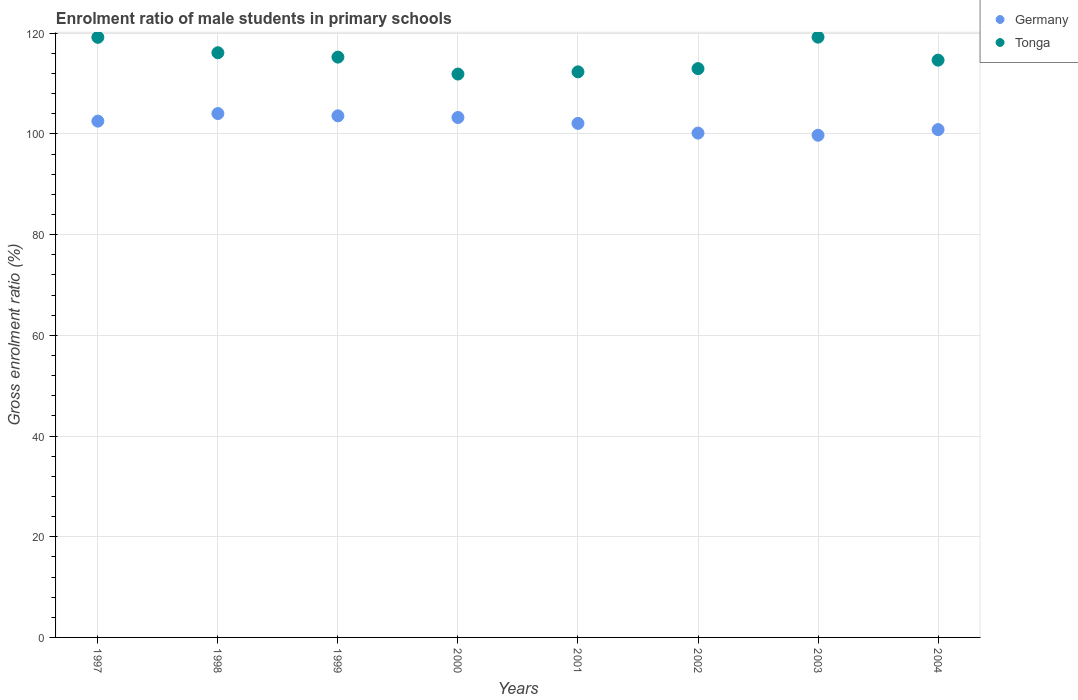What is the enrolment ratio of male students in primary schools in Tonga in 1999?
Give a very brief answer. 115.27. Across all years, what is the maximum enrolment ratio of male students in primary schools in Tonga?
Make the answer very short. 119.24. Across all years, what is the minimum enrolment ratio of male students in primary schools in Tonga?
Offer a terse response. 111.91. In which year was the enrolment ratio of male students in primary schools in Tonga maximum?
Your answer should be compact. 2003. In which year was the enrolment ratio of male students in primary schools in Tonga minimum?
Your answer should be very brief. 2000. What is the total enrolment ratio of male students in primary schools in Germany in the graph?
Your answer should be very brief. 816.41. What is the difference between the enrolment ratio of male students in primary schools in Tonga in 2002 and that in 2004?
Make the answer very short. -1.69. What is the difference between the enrolment ratio of male students in primary schools in Tonga in 2003 and the enrolment ratio of male students in primary schools in Germany in 1999?
Your response must be concise. 15.63. What is the average enrolment ratio of male students in primary schools in Tonga per year?
Your answer should be compact. 115.22. In the year 1999, what is the difference between the enrolment ratio of male students in primary schools in Germany and enrolment ratio of male students in primary schools in Tonga?
Offer a very short reply. -11.66. In how many years, is the enrolment ratio of male students in primary schools in Tonga greater than 60 %?
Make the answer very short. 8. What is the ratio of the enrolment ratio of male students in primary schools in Tonga in 2003 to that in 2004?
Provide a short and direct response. 1.04. Is the enrolment ratio of male students in primary schools in Tonga in 1997 less than that in 2001?
Make the answer very short. No. What is the difference between the highest and the second highest enrolment ratio of male students in primary schools in Tonga?
Offer a terse response. 0.03. What is the difference between the highest and the lowest enrolment ratio of male students in primary schools in Tonga?
Ensure brevity in your answer.  7.33. How many dotlines are there?
Your answer should be very brief. 2. What is the difference between two consecutive major ticks on the Y-axis?
Provide a succinct answer. 20. Are the values on the major ticks of Y-axis written in scientific E-notation?
Make the answer very short. No. Does the graph contain any zero values?
Your answer should be compact. No. How are the legend labels stacked?
Provide a short and direct response. Vertical. What is the title of the graph?
Provide a succinct answer. Enrolment ratio of male students in primary schools. What is the label or title of the Y-axis?
Your answer should be compact. Gross enrolment ratio (%). What is the Gross enrolment ratio (%) in Germany in 1997?
Provide a short and direct response. 102.56. What is the Gross enrolment ratio (%) in Tonga in 1997?
Your answer should be compact. 119.2. What is the Gross enrolment ratio (%) in Germany in 1998?
Provide a succinct answer. 104.06. What is the Gross enrolment ratio (%) in Tonga in 1998?
Your answer should be very brief. 116.14. What is the Gross enrolment ratio (%) of Germany in 1999?
Offer a terse response. 103.61. What is the Gross enrolment ratio (%) of Tonga in 1999?
Your answer should be compact. 115.27. What is the Gross enrolment ratio (%) of Germany in 2000?
Your answer should be very brief. 103.28. What is the Gross enrolment ratio (%) in Tonga in 2000?
Your response must be concise. 111.91. What is the Gross enrolment ratio (%) in Germany in 2001?
Make the answer very short. 102.1. What is the Gross enrolment ratio (%) in Tonga in 2001?
Give a very brief answer. 112.34. What is the Gross enrolment ratio (%) of Germany in 2002?
Provide a succinct answer. 100.18. What is the Gross enrolment ratio (%) of Tonga in 2002?
Keep it short and to the point. 112.98. What is the Gross enrolment ratio (%) of Germany in 2003?
Your answer should be compact. 99.75. What is the Gross enrolment ratio (%) of Tonga in 2003?
Provide a short and direct response. 119.24. What is the Gross enrolment ratio (%) of Germany in 2004?
Provide a short and direct response. 100.87. What is the Gross enrolment ratio (%) in Tonga in 2004?
Your response must be concise. 114.67. Across all years, what is the maximum Gross enrolment ratio (%) of Germany?
Make the answer very short. 104.06. Across all years, what is the maximum Gross enrolment ratio (%) in Tonga?
Keep it short and to the point. 119.24. Across all years, what is the minimum Gross enrolment ratio (%) in Germany?
Offer a very short reply. 99.75. Across all years, what is the minimum Gross enrolment ratio (%) in Tonga?
Offer a terse response. 111.91. What is the total Gross enrolment ratio (%) in Germany in the graph?
Your answer should be compact. 816.41. What is the total Gross enrolment ratio (%) of Tonga in the graph?
Provide a short and direct response. 921.76. What is the difference between the Gross enrolment ratio (%) in Germany in 1997 and that in 1998?
Your answer should be very brief. -1.5. What is the difference between the Gross enrolment ratio (%) in Tonga in 1997 and that in 1998?
Ensure brevity in your answer.  3.06. What is the difference between the Gross enrolment ratio (%) of Germany in 1997 and that in 1999?
Keep it short and to the point. -1.05. What is the difference between the Gross enrolment ratio (%) of Tonga in 1997 and that in 1999?
Provide a succinct answer. 3.93. What is the difference between the Gross enrolment ratio (%) in Germany in 1997 and that in 2000?
Ensure brevity in your answer.  -0.72. What is the difference between the Gross enrolment ratio (%) of Tonga in 1997 and that in 2000?
Provide a short and direct response. 7.29. What is the difference between the Gross enrolment ratio (%) of Germany in 1997 and that in 2001?
Your response must be concise. 0.45. What is the difference between the Gross enrolment ratio (%) of Tonga in 1997 and that in 2001?
Offer a terse response. 6.86. What is the difference between the Gross enrolment ratio (%) in Germany in 1997 and that in 2002?
Ensure brevity in your answer.  2.38. What is the difference between the Gross enrolment ratio (%) of Tonga in 1997 and that in 2002?
Make the answer very short. 6.22. What is the difference between the Gross enrolment ratio (%) of Germany in 1997 and that in 2003?
Your response must be concise. 2.81. What is the difference between the Gross enrolment ratio (%) of Tonga in 1997 and that in 2003?
Your answer should be very brief. -0.03. What is the difference between the Gross enrolment ratio (%) in Germany in 1997 and that in 2004?
Your answer should be very brief. 1.69. What is the difference between the Gross enrolment ratio (%) of Tonga in 1997 and that in 2004?
Ensure brevity in your answer.  4.53. What is the difference between the Gross enrolment ratio (%) in Germany in 1998 and that in 1999?
Your answer should be very brief. 0.45. What is the difference between the Gross enrolment ratio (%) in Tonga in 1998 and that in 1999?
Provide a short and direct response. 0.87. What is the difference between the Gross enrolment ratio (%) of Germany in 1998 and that in 2000?
Provide a short and direct response. 0.79. What is the difference between the Gross enrolment ratio (%) of Tonga in 1998 and that in 2000?
Keep it short and to the point. 4.23. What is the difference between the Gross enrolment ratio (%) of Germany in 1998 and that in 2001?
Ensure brevity in your answer.  1.96. What is the difference between the Gross enrolment ratio (%) in Tonga in 1998 and that in 2001?
Keep it short and to the point. 3.8. What is the difference between the Gross enrolment ratio (%) of Germany in 1998 and that in 2002?
Give a very brief answer. 3.88. What is the difference between the Gross enrolment ratio (%) of Tonga in 1998 and that in 2002?
Offer a terse response. 3.16. What is the difference between the Gross enrolment ratio (%) in Germany in 1998 and that in 2003?
Your response must be concise. 4.31. What is the difference between the Gross enrolment ratio (%) of Tonga in 1998 and that in 2003?
Your response must be concise. -3.09. What is the difference between the Gross enrolment ratio (%) in Germany in 1998 and that in 2004?
Offer a very short reply. 3.19. What is the difference between the Gross enrolment ratio (%) in Tonga in 1998 and that in 2004?
Your answer should be very brief. 1.47. What is the difference between the Gross enrolment ratio (%) of Germany in 1999 and that in 2000?
Keep it short and to the point. 0.33. What is the difference between the Gross enrolment ratio (%) in Tonga in 1999 and that in 2000?
Offer a terse response. 3.36. What is the difference between the Gross enrolment ratio (%) in Germany in 1999 and that in 2001?
Provide a succinct answer. 1.51. What is the difference between the Gross enrolment ratio (%) of Tonga in 1999 and that in 2001?
Ensure brevity in your answer.  2.93. What is the difference between the Gross enrolment ratio (%) of Germany in 1999 and that in 2002?
Offer a very short reply. 3.43. What is the difference between the Gross enrolment ratio (%) of Tonga in 1999 and that in 2002?
Provide a succinct answer. 2.29. What is the difference between the Gross enrolment ratio (%) in Germany in 1999 and that in 2003?
Your answer should be very brief. 3.86. What is the difference between the Gross enrolment ratio (%) of Tonga in 1999 and that in 2003?
Your answer should be very brief. -3.97. What is the difference between the Gross enrolment ratio (%) of Germany in 1999 and that in 2004?
Offer a very short reply. 2.74. What is the difference between the Gross enrolment ratio (%) of Tonga in 1999 and that in 2004?
Offer a very short reply. 0.6. What is the difference between the Gross enrolment ratio (%) in Germany in 2000 and that in 2001?
Offer a very short reply. 1.17. What is the difference between the Gross enrolment ratio (%) of Tonga in 2000 and that in 2001?
Ensure brevity in your answer.  -0.44. What is the difference between the Gross enrolment ratio (%) of Germany in 2000 and that in 2002?
Give a very brief answer. 3.1. What is the difference between the Gross enrolment ratio (%) of Tonga in 2000 and that in 2002?
Provide a short and direct response. -1.07. What is the difference between the Gross enrolment ratio (%) in Germany in 2000 and that in 2003?
Make the answer very short. 3.52. What is the difference between the Gross enrolment ratio (%) in Tonga in 2000 and that in 2003?
Offer a very short reply. -7.33. What is the difference between the Gross enrolment ratio (%) in Germany in 2000 and that in 2004?
Your answer should be compact. 2.41. What is the difference between the Gross enrolment ratio (%) of Tonga in 2000 and that in 2004?
Make the answer very short. -2.76. What is the difference between the Gross enrolment ratio (%) of Germany in 2001 and that in 2002?
Your answer should be very brief. 1.93. What is the difference between the Gross enrolment ratio (%) of Tonga in 2001 and that in 2002?
Give a very brief answer. -0.64. What is the difference between the Gross enrolment ratio (%) of Germany in 2001 and that in 2003?
Ensure brevity in your answer.  2.35. What is the difference between the Gross enrolment ratio (%) in Tonga in 2001 and that in 2003?
Your answer should be very brief. -6.89. What is the difference between the Gross enrolment ratio (%) in Germany in 2001 and that in 2004?
Your answer should be compact. 1.23. What is the difference between the Gross enrolment ratio (%) in Tonga in 2001 and that in 2004?
Provide a succinct answer. -2.33. What is the difference between the Gross enrolment ratio (%) in Germany in 2002 and that in 2003?
Your answer should be very brief. 0.43. What is the difference between the Gross enrolment ratio (%) of Tonga in 2002 and that in 2003?
Your response must be concise. -6.25. What is the difference between the Gross enrolment ratio (%) of Germany in 2002 and that in 2004?
Your answer should be very brief. -0.69. What is the difference between the Gross enrolment ratio (%) of Tonga in 2002 and that in 2004?
Offer a terse response. -1.69. What is the difference between the Gross enrolment ratio (%) in Germany in 2003 and that in 2004?
Make the answer very short. -1.12. What is the difference between the Gross enrolment ratio (%) in Tonga in 2003 and that in 2004?
Ensure brevity in your answer.  4.57. What is the difference between the Gross enrolment ratio (%) of Germany in 1997 and the Gross enrolment ratio (%) of Tonga in 1998?
Provide a succinct answer. -13.58. What is the difference between the Gross enrolment ratio (%) of Germany in 1997 and the Gross enrolment ratio (%) of Tonga in 1999?
Your response must be concise. -12.71. What is the difference between the Gross enrolment ratio (%) in Germany in 1997 and the Gross enrolment ratio (%) in Tonga in 2000?
Your answer should be very brief. -9.35. What is the difference between the Gross enrolment ratio (%) of Germany in 1997 and the Gross enrolment ratio (%) of Tonga in 2001?
Make the answer very short. -9.79. What is the difference between the Gross enrolment ratio (%) of Germany in 1997 and the Gross enrolment ratio (%) of Tonga in 2002?
Your answer should be very brief. -10.42. What is the difference between the Gross enrolment ratio (%) of Germany in 1997 and the Gross enrolment ratio (%) of Tonga in 2003?
Give a very brief answer. -16.68. What is the difference between the Gross enrolment ratio (%) in Germany in 1997 and the Gross enrolment ratio (%) in Tonga in 2004?
Your response must be concise. -12.11. What is the difference between the Gross enrolment ratio (%) in Germany in 1998 and the Gross enrolment ratio (%) in Tonga in 1999?
Provide a succinct answer. -11.21. What is the difference between the Gross enrolment ratio (%) in Germany in 1998 and the Gross enrolment ratio (%) in Tonga in 2000?
Ensure brevity in your answer.  -7.85. What is the difference between the Gross enrolment ratio (%) of Germany in 1998 and the Gross enrolment ratio (%) of Tonga in 2001?
Offer a very short reply. -8.28. What is the difference between the Gross enrolment ratio (%) of Germany in 1998 and the Gross enrolment ratio (%) of Tonga in 2002?
Make the answer very short. -8.92. What is the difference between the Gross enrolment ratio (%) in Germany in 1998 and the Gross enrolment ratio (%) in Tonga in 2003?
Give a very brief answer. -15.18. What is the difference between the Gross enrolment ratio (%) of Germany in 1998 and the Gross enrolment ratio (%) of Tonga in 2004?
Provide a short and direct response. -10.61. What is the difference between the Gross enrolment ratio (%) in Germany in 1999 and the Gross enrolment ratio (%) in Tonga in 2000?
Give a very brief answer. -8.3. What is the difference between the Gross enrolment ratio (%) in Germany in 1999 and the Gross enrolment ratio (%) in Tonga in 2001?
Your answer should be very brief. -8.73. What is the difference between the Gross enrolment ratio (%) in Germany in 1999 and the Gross enrolment ratio (%) in Tonga in 2002?
Provide a short and direct response. -9.37. What is the difference between the Gross enrolment ratio (%) in Germany in 1999 and the Gross enrolment ratio (%) in Tonga in 2003?
Your answer should be compact. -15.63. What is the difference between the Gross enrolment ratio (%) of Germany in 1999 and the Gross enrolment ratio (%) of Tonga in 2004?
Keep it short and to the point. -11.06. What is the difference between the Gross enrolment ratio (%) of Germany in 2000 and the Gross enrolment ratio (%) of Tonga in 2001?
Your response must be concise. -9.07. What is the difference between the Gross enrolment ratio (%) in Germany in 2000 and the Gross enrolment ratio (%) in Tonga in 2002?
Your response must be concise. -9.71. What is the difference between the Gross enrolment ratio (%) in Germany in 2000 and the Gross enrolment ratio (%) in Tonga in 2003?
Keep it short and to the point. -15.96. What is the difference between the Gross enrolment ratio (%) of Germany in 2000 and the Gross enrolment ratio (%) of Tonga in 2004?
Offer a very short reply. -11.39. What is the difference between the Gross enrolment ratio (%) in Germany in 2001 and the Gross enrolment ratio (%) in Tonga in 2002?
Provide a succinct answer. -10.88. What is the difference between the Gross enrolment ratio (%) in Germany in 2001 and the Gross enrolment ratio (%) in Tonga in 2003?
Provide a short and direct response. -17.13. What is the difference between the Gross enrolment ratio (%) of Germany in 2001 and the Gross enrolment ratio (%) of Tonga in 2004?
Your response must be concise. -12.57. What is the difference between the Gross enrolment ratio (%) in Germany in 2002 and the Gross enrolment ratio (%) in Tonga in 2003?
Provide a short and direct response. -19.06. What is the difference between the Gross enrolment ratio (%) in Germany in 2002 and the Gross enrolment ratio (%) in Tonga in 2004?
Give a very brief answer. -14.49. What is the difference between the Gross enrolment ratio (%) in Germany in 2003 and the Gross enrolment ratio (%) in Tonga in 2004?
Your response must be concise. -14.92. What is the average Gross enrolment ratio (%) of Germany per year?
Give a very brief answer. 102.05. What is the average Gross enrolment ratio (%) of Tonga per year?
Give a very brief answer. 115.22. In the year 1997, what is the difference between the Gross enrolment ratio (%) in Germany and Gross enrolment ratio (%) in Tonga?
Your answer should be very brief. -16.64. In the year 1998, what is the difference between the Gross enrolment ratio (%) of Germany and Gross enrolment ratio (%) of Tonga?
Your response must be concise. -12.08. In the year 1999, what is the difference between the Gross enrolment ratio (%) in Germany and Gross enrolment ratio (%) in Tonga?
Ensure brevity in your answer.  -11.66. In the year 2000, what is the difference between the Gross enrolment ratio (%) in Germany and Gross enrolment ratio (%) in Tonga?
Ensure brevity in your answer.  -8.63. In the year 2001, what is the difference between the Gross enrolment ratio (%) of Germany and Gross enrolment ratio (%) of Tonga?
Provide a short and direct response. -10.24. In the year 2002, what is the difference between the Gross enrolment ratio (%) in Germany and Gross enrolment ratio (%) in Tonga?
Keep it short and to the point. -12.8. In the year 2003, what is the difference between the Gross enrolment ratio (%) in Germany and Gross enrolment ratio (%) in Tonga?
Provide a succinct answer. -19.48. In the year 2004, what is the difference between the Gross enrolment ratio (%) of Germany and Gross enrolment ratio (%) of Tonga?
Ensure brevity in your answer.  -13.8. What is the ratio of the Gross enrolment ratio (%) in Germany in 1997 to that in 1998?
Provide a succinct answer. 0.99. What is the ratio of the Gross enrolment ratio (%) in Tonga in 1997 to that in 1998?
Make the answer very short. 1.03. What is the ratio of the Gross enrolment ratio (%) in Germany in 1997 to that in 1999?
Your answer should be very brief. 0.99. What is the ratio of the Gross enrolment ratio (%) in Tonga in 1997 to that in 1999?
Your answer should be very brief. 1.03. What is the ratio of the Gross enrolment ratio (%) in Germany in 1997 to that in 2000?
Give a very brief answer. 0.99. What is the ratio of the Gross enrolment ratio (%) in Tonga in 1997 to that in 2000?
Offer a very short reply. 1.07. What is the ratio of the Gross enrolment ratio (%) of Tonga in 1997 to that in 2001?
Offer a very short reply. 1.06. What is the ratio of the Gross enrolment ratio (%) in Germany in 1997 to that in 2002?
Your answer should be compact. 1.02. What is the ratio of the Gross enrolment ratio (%) of Tonga in 1997 to that in 2002?
Offer a terse response. 1.06. What is the ratio of the Gross enrolment ratio (%) of Germany in 1997 to that in 2003?
Ensure brevity in your answer.  1.03. What is the ratio of the Gross enrolment ratio (%) of Germany in 1997 to that in 2004?
Provide a succinct answer. 1.02. What is the ratio of the Gross enrolment ratio (%) in Tonga in 1997 to that in 2004?
Your answer should be compact. 1.04. What is the ratio of the Gross enrolment ratio (%) in Germany in 1998 to that in 1999?
Ensure brevity in your answer.  1. What is the ratio of the Gross enrolment ratio (%) in Tonga in 1998 to that in 1999?
Your answer should be very brief. 1.01. What is the ratio of the Gross enrolment ratio (%) in Germany in 1998 to that in 2000?
Provide a succinct answer. 1.01. What is the ratio of the Gross enrolment ratio (%) in Tonga in 1998 to that in 2000?
Make the answer very short. 1.04. What is the ratio of the Gross enrolment ratio (%) in Germany in 1998 to that in 2001?
Give a very brief answer. 1.02. What is the ratio of the Gross enrolment ratio (%) of Tonga in 1998 to that in 2001?
Give a very brief answer. 1.03. What is the ratio of the Gross enrolment ratio (%) of Germany in 1998 to that in 2002?
Your answer should be very brief. 1.04. What is the ratio of the Gross enrolment ratio (%) of Tonga in 1998 to that in 2002?
Ensure brevity in your answer.  1.03. What is the ratio of the Gross enrolment ratio (%) of Germany in 1998 to that in 2003?
Keep it short and to the point. 1.04. What is the ratio of the Gross enrolment ratio (%) of Tonga in 1998 to that in 2003?
Offer a very short reply. 0.97. What is the ratio of the Gross enrolment ratio (%) in Germany in 1998 to that in 2004?
Offer a terse response. 1.03. What is the ratio of the Gross enrolment ratio (%) in Tonga in 1998 to that in 2004?
Your answer should be compact. 1.01. What is the ratio of the Gross enrolment ratio (%) in Germany in 1999 to that in 2000?
Give a very brief answer. 1. What is the ratio of the Gross enrolment ratio (%) of Tonga in 1999 to that in 2000?
Make the answer very short. 1.03. What is the ratio of the Gross enrolment ratio (%) in Germany in 1999 to that in 2001?
Your response must be concise. 1.01. What is the ratio of the Gross enrolment ratio (%) of Tonga in 1999 to that in 2001?
Offer a very short reply. 1.03. What is the ratio of the Gross enrolment ratio (%) of Germany in 1999 to that in 2002?
Give a very brief answer. 1.03. What is the ratio of the Gross enrolment ratio (%) in Tonga in 1999 to that in 2002?
Make the answer very short. 1.02. What is the ratio of the Gross enrolment ratio (%) in Germany in 1999 to that in 2003?
Offer a very short reply. 1.04. What is the ratio of the Gross enrolment ratio (%) in Tonga in 1999 to that in 2003?
Give a very brief answer. 0.97. What is the ratio of the Gross enrolment ratio (%) in Germany in 1999 to that in 2004?
Your answer should be compact. 1.03. What is the ratio of the Gross enrolment ratio (%) in Germany in 2000 to that in 2001?
Your answer should be very brief. 1.01. What is the ratio of the Gross enrolment ratio (%) in Germany in 2000 to that in 2002?
Provide a short and direct response. 1.03. What is the ratio of the Gross enrolment ratio (%) of Tonga in 2000 to that in 2002?
Keep it short and to the point. 0.99. What is the ratio of the Gross enrolment ratio (%) in Germany in 2000 to that in 2003?
Keep it short and to the point. 1.04. What is the ratio of the Gross enrolment ratio (%) in Tonga in 2000 to that in 2003?
Your answer should be very brief. 0.94. What is the ratio of the Gross enrolment ratio (%) in Germany in 2000 to that in 2004?
Give a very brief answer. 1.02. What is the ratio of the Gross enrolment ratio (%) of Tonga in 2000 to that in 2004?
Your answer should be compact. 0.98. What is the ratio of the Gross enrolment ratio (%) in Germany in 2001 to that in 2002?
Your answer should be compact. 1.02. What is the ratio of the Gross enrolment ratio (%) of Germany in 2001 to that in 2003?
Offer a terse response. 1.02. What is the ratio of the Gross enrolment ratio (%) in Tonga in 2001 to that in 2003?
Provide a succinct answer. 0.94. What is the ratio of the Gross enrolment ratio (%) in Germany in 2001 to that in 2004?
Provide a short and direct response. 1.01. What is the ratio of the Gross enrolment ratio (%) of Tonga in 2001 to that in 2004?
Ensure brevity in your answer.  0.98. What is the ratio of the Gross enrolment ratio (%) in Tonga in 2002 to that in 2003?
Make the answer very short. 0.95. What is the ratio of the Gross enrolment ratio (%) in Germany in 2003 to that in 2004?
Offer a very short reply. 0.99. What is the ratio of the Gross enrolment ratio (%) of Tonga in 2003 to that in 2004?
Offer a terse response. 1.04. What is the difference between the highest and the second highest Gross enrolment ratio (%) in Germany?
Keep it short and to the point. 0.45. What is the difference between the highest and the second highest Gross enrolment ratio (%) of Tonga?
Provide a short and direct response. 0.03. What is the difference between the highest and the lowest Gross enrolment ratio (%) of Germany?
Make the answer very short. 4.31. What is the difference between the highest and the lowest Gross enrolment ratio (%) of Tonga?
Your response must be concise. 7.33. 